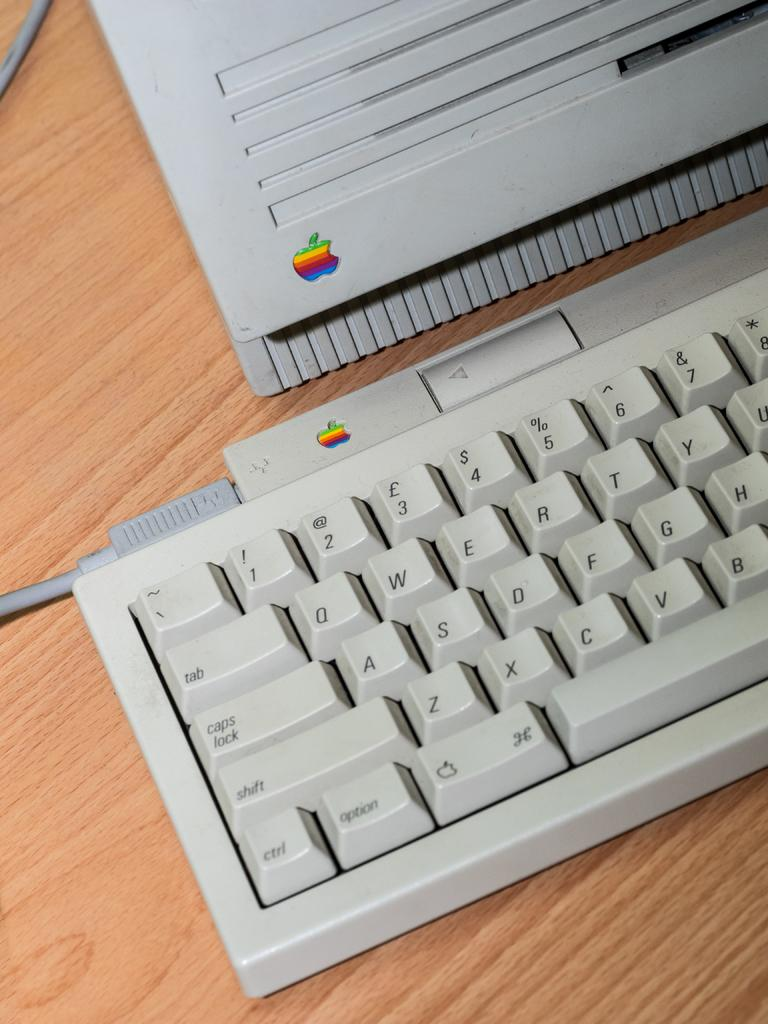<image>
Give a short and clear explanation of the subsequent image. An old Macintosh computer with the rainbow colored apple emblazoned on it. 